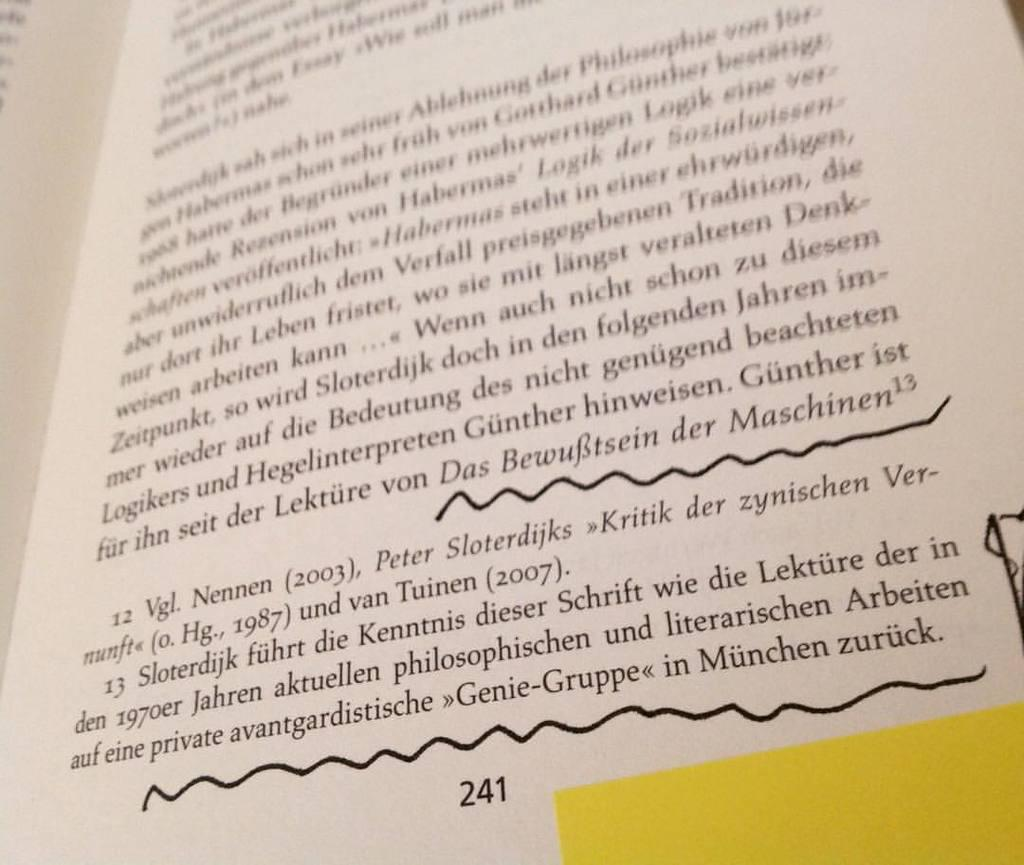<image>
Present a compact description of the photo's key features. Two lines are underlined on page 241 of a book written in German. 